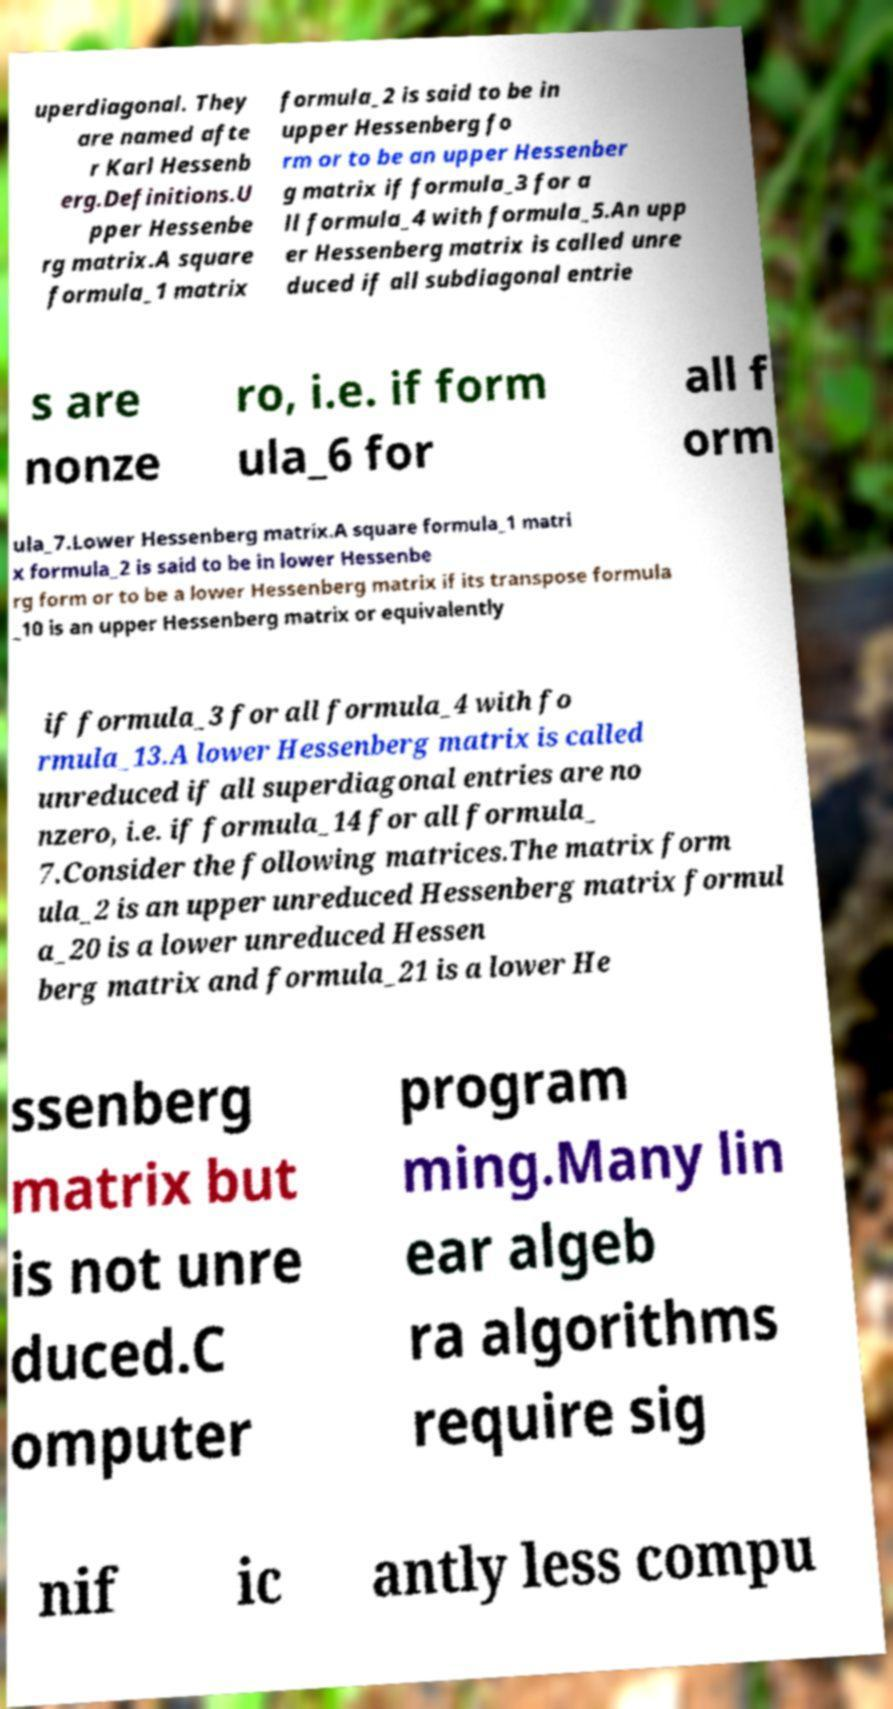Could you assist in decoding the text presented in this image and type it out clearly? uperdiagonal. They are named afte r Karl Hessenb erg.Definitions.U pper Hessenbe rg matrix.A square formula_1 matrix formula_2 is said to be in upper Hessenberg fo rm or to be an upper Hessenber g matrix if formula_3 for a ll formula_4 with formula_5.An upp er Hessenberg matrix is called unre duced if all subdiagonal entrie s are nonze ro, i.e. if form ula_6 for all f orm ula_7.Lower Hessenberg matrix.A square formula_1 matri x formula_2 is said to be in lower Hessenbe rg form or to be a lower Hessenberg matrix if its transpose formula _10 is an upper Hessenberg matrix or equivalently if formula_3 for all formula_4 with fo rmula_13.A lower Hessenberg matrix is called unreduced if all superdiagonal entries are no nzero, i.e. if formula_14 for all formula_ 7.Consider the following matrices.The matrix form ula_2 is an upper unreduced Hessenberg matrix formul a_20 is a lower unreduced Hessen berg matrix and formula_21 is a lower He ssenberg matrix but is not unre duced.C omputer program ming.Many lin ear algeb ra algorithms require sig nif ic antly less compu 